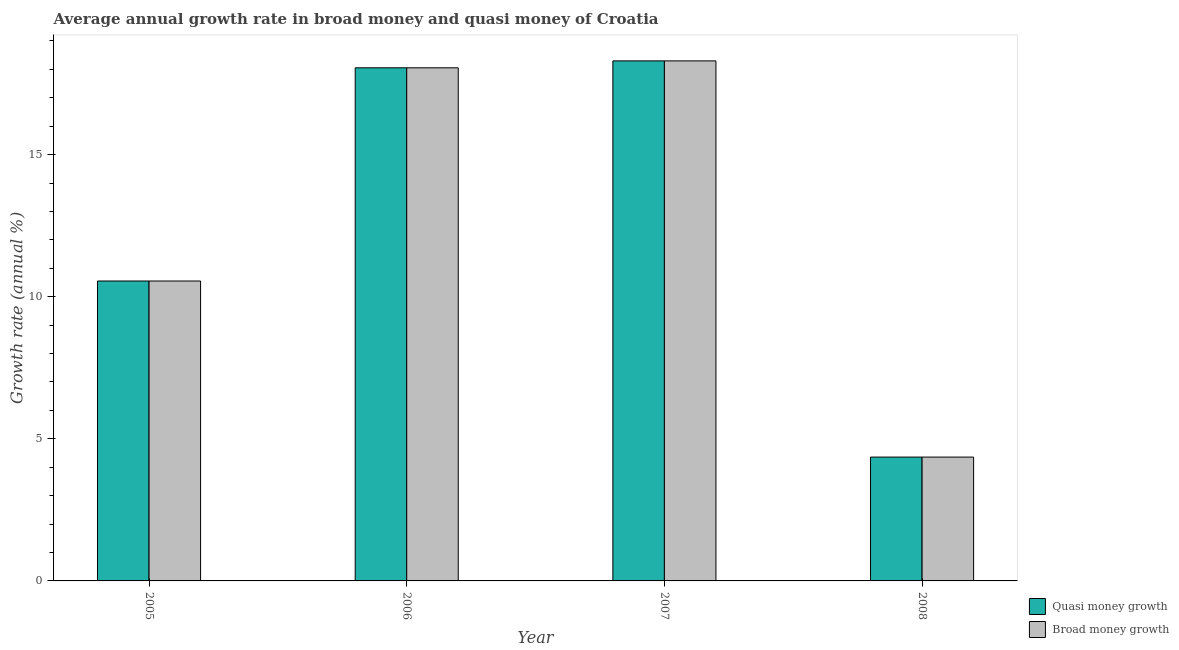How many groups of bars are there?
Give a very brief answer. 4. Are the number of bars per tick equal to the number of legend labels?
Offer a very short reply. Yes. Are the number of bars on each tick of the X-axis equal?
Offer a terse response. Yes. How many bars are there on the 3rd tick from the left?
Give a very brief answer. 2. How many bars are there on the 2nd tick from the right?
Give a very brief answer. 2. What is the annual growth rate in broad money in 2005?
Offer a very short reply. 10.55. Across all years, what is the maximum annual growth rate in broad money?
Provide a short and direct response. 18.3. Across all years, what is the minimum annual growth rate in broad money?
Provide a short and direct response. 4.36. In which year was the annual growth rate in quasi money maximum?
Provide a short and direct response. 2007. In which year was the annual growth rate in quasi money minimum?
Offer a terse response. 2008. What is the total annual growth rate in quasi money in the graph?
Provide a succinct answer. 51.26. What is the difference between the annual growth rate in quasi money in 2005 and that in 2007?
Offer a terse response. -7.75. What is the difference between the annual growth rate in broad money in 2006 and the annual growth rate in quasi money in 2007?
Your answer should be compact. -0.24. What is the average annual growth rate in broad money per year?
Make the answer very short. 12.81. In the year 2005, what is the difference between the annual growth rate in quasi money and annual growth rate in broad money?
Keep it short and to the point. 0. What is the ratio of the annual growth rate in quasi money in 2006 to that in 2008?
Keep it short and to the point. 4.14. Is the difference between the annual growth rate in quasi money in 2006 and 2007 greater than the difference between the annual growth rate in broad money in 2006 and 2007?
Your response must be concise. No. What is the difference between the highest and the second highest annual growth rate in quasi money?
Your response must be concise. 0.24. What is the difference between the highest and the lowest annual growth rate in quasi money?
Your answer should be very brief. 13.94. What does the 2nd bar from the left in 2005 represents?
Offer a very short reply. Broad money growth. What does the 2nd bar from the right in 2008 represents?
Provide a short and direct response. Quasi money growth. Are all the bars in the graph horizontal?
Your answer should be compact. No. How many years are there in the graph?
Your answer should be compact. 4. Does the graph contain grids?
Provide a short and direct response. No. How many legend labels are there?
Provide a short and direct response. 2. What is the title of the graph?
Provide a short and direct response. Average annual growth rate in broad money and quasi money of Croatia. What is the label or title of the X-axis?
Make the answer very short. Year. What is the label or title of the Y-axis?
Provide a succinct answer. Growth rate (annual %). What is the Growth rate (annual %) in Quasi money growth in 2005?
Offer a terse response. 10.55. What is the Growth rate (annual %) in Broad money growth in 2005?
Your answer should be very brief. 10.55. What is the Growth rate (annual %) in Quasi money growth in 2006?
Ensure brevity in your answer.  18.05. What is the Growth rate (annual %) of Broad money growth in 2006?
Provide a short and direct response. 18.05. What is the Growth rate (annual %) of Quasi money growth in 2007?
Your answer should be compact. 18.3. What is the Growth rate (annual %) of Broad money growth in 2007?
Provide a succinct answer. 18.3. What is the Growth rate (annual %) of Quasi money growth in 2008?
Your answer should be compact. 4.36. What is the Growth rate (annual %) of Broad money growth in 2008?
Your response must be concise. 4.36. Across all years, what is the maximum Growth rate (annual %) of Quasi money growth?
Ensure brevity in your answer.  18.3. Across all years, what is the maximum Growth rate (annual %) of Broad money growth?
Your answer should be compact. 18.3. Across all years, what is the minimum Growth rate (annual %) of Quasi money growth?
Your answer should be very brief. 4.36. Across all years, what is the minimum Growth rate (annual %) of Broad money growth?
Give a very brief answer. 4.36. What is the total Growth rate (annual %) in Quasi money growth in the graph?
Your response must be concise. 51.26. What is the total Growth rate (annual %) in Broad money growth in the graph?
Offer a very short reply. 51.26. What is the difference between the Growth rate (annual %) of Quasi money growth in 2005 and that in 2006?
Keep it short and to the point. -7.5. What is the difference between the Growth rate (annual %) of Broad money growth in 2005 and that in 2006?
Offer a very short reply. -7.5. What is the difference between the Growth rate (annual %) in Quasi money growth in 2005 and that in 2007?
Your answer should be very brief. -7.75. What is the difference between the Growth rate (annual %) in Broad money growth in 2005 and that in 2007?
Provide a succinct answer. -7.75. What is the difference between the Growth rate (annual %) of Quasi money growth in 2005 and that in 2008?
Give a very brief answer. 6.2. What is the difference between the Growth rate (annual %) in Broad money growth in 2005 and that in 2008?
Keep it short and to the point. 6.2. What is the difference between the Growth rate (annual %) of Quasi money growth in 2006 and that in 2007?
Give a very brief answer. -0.24. What is the difference between the Growth rate (annual %) of Broad money growth in 2006 and that in 2007?
Ensure brevity in your answer.  -0.24. What is the difference between the Growth rate (annual %) of Quasi money growth in 2006 and that in 2008?
Provide a short and direct response. 13.7. What is the difference between the Growth rate (annual %) of Broad money growth in 2006 and that in 2008?
Your answer should be compact. 13.7. What is the difference between the Growth rate (annual %) in Quasi money growth in 2007 and that in 2008?
Give a very brief answer. 13.94. What is the difference between the Growth rate (annual %) in Broad money growth in 2007 and that in 2008?
Give a very brief answer. 13.94. What is the difference between the Growth rate (annual %) in Quasi money growth in 2005 and the Growth rate (annual %) in Broad money growth in 2006?
Your answer should be very brief. -7.5. What is the difference between the Growth rate (annual %) in Quasi money growth in 2005 and the Growth rate (annual %) in Broad money growth in 2007?
Your response must be concise. -7.75. What is the difference between the Growth rate (annual %) of Quasi money growth in 2005 and the Growth rate (annual %) of Broad money growth in 2008?
Ensure brevity in your answer.  6.2. What is the difference between the Growth rate (annual %) of Quasi money growth in 2006 and the Growth rate (annual %) of Broad money growth in 2007?
Make the answer very short. -0.24. What is the difference between the Growth rate (annual %) of Quasi money growth in 2006 and the Growth rate (annual %) of Broad money growth in 2008?
Make the answer very short. 13.7. What is the difference between the Growth rate (annual %) of Quasi money growth in 2007 and the Growth rate (annual %) of Broad money growth in 2008?
Provide a succinct answer. 13.94. What is the average Growth rate (annual %) in Quasi money growth per year?
Make the answer very short. 12.81. What is the average Growth rate (annual %) in Broad money growth per year?
Offer a terse response. 12.81. In the year 2006, what is the difference between the Growth rate (annual %) in Quasi money growth and Growth rate (annual %) in Broad money growth?
Your answer should be very brief. 0. In the year 2008, what is the difference between the Growth rate (annual %) in Quasi money growth and Growth rate (annual %) in Broad money growth?
Your answer should be very brief. 0. What is the ratio of the Growth rate (annual %) in Quasi money growth in 2005 to that in 2006?
Your response must be concise. 0.58. What is the ratio of the Growth rate (annual %) in Broad money growth in 2005 to that in 2006?
Your response must be concise. 0.58. What is the ratio of the Growth rate (annual %) in Quasi money growth in 2005 to that in 2007?
Your answer should be compact. 0.58. What is the ratio of the Growth rate (annual %) of Broad money growth in 2005 to that in 2007?
Provide a short and direct response. 0.58. What is the ratio of the Growth rate (annual %) of Quasi money growth in 2005 to that in 2008?
Your answer should be very brief. 2.42. What is the ratio of the Growth rate (annual %) in Broad money growth in 2005 to that in 2008?
Offer a terse response. 2.42. What is the ratio of the Growth rate (annual %) of Quasi money growth in 2006 to that in 2007?
Offer a very short reply. 0.99. What is the ratio of the Growth rate (annual %) of Broad money growth in 2006 to that in 2007?
Give a very brief answer. 0.99. What is the ratio of the Growth rate (annual %) in Quasi money growth in 2006 to that in 2008?
Your answer should be compact. 4.14. What is the ratio of the Growth rate (annual %) in Broad money growth in 2006 to that in 2008?
Ensure brevity in your answer.  4.14. What is the ratio of the Growth rate (annual %) of Quasi money growth in 2007 to that in 2008?
Your answer should be very brief. 4.2. What is the ratio of the Growth rate (annual %) of Broad money growth in 2007 to that in 2008?
Provide a succinct answer. 4.2. What is the difference between the highest and the second highest Growth rate (annual %) in Quasi money growth?
Provide a succinct answer. 0.24. What is the difference between the highest and the second highest Growth rate (annual %) in Broad money growth?
Offer a very short reply. 0.24. What is the difference between the highest and the lowest Growth rate (annual %) of Quasi money growth?
Give a very brief answer. 13.94. What is the difference between the highest and the lowest Growth rate (annual %) in Broad money growth?
Keep it short and to the point. 13.94. 